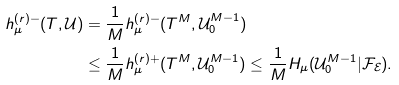<formula> <loc_0><loc_0><loc_500><loc_500>h _ { \mu } ^ { ( r ) - } ( T , \mathcal { U } ) & = \frac { 1 } { M } h _ { \mu } ^ { ( r ) - } ( T ^ { M } , \mathcal { U } _ { 0 } ^ { M - 1 } ) \\ & \leq \frac { 1 } { M } h _ { \mu } ^ { ( r ) + } ( T ^ { M } , \mathcal { U } _ { 0 } ^ { M - 1 } ) \leq \frac { 1 } { M } H _ { \mu } ( \mathcal { U } _ { 0 } ^ { M - 1 } | \mathcal { F } _ { \mathcal { E } } ) .</formula> 